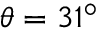Convert formula to latex. <formula><loc_0><loc_0><loc_500><loc_500>\theta = 3 1 ^ { \circ }</formula> 